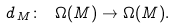<formula> <loc_0><loc_0><loc_500><loc_500>d _ { \, M } \colon \ \Omega ( M ) \rightarrow \Omega ( M ) .</formula> 